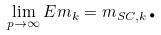Convert formula to latex. <formula><loc_0><loc_0><loc_500><loc_500>\lim _ { p \rightarrow \infty } E m _ { k } = m _ { S C , k } \text {.}</formula> 